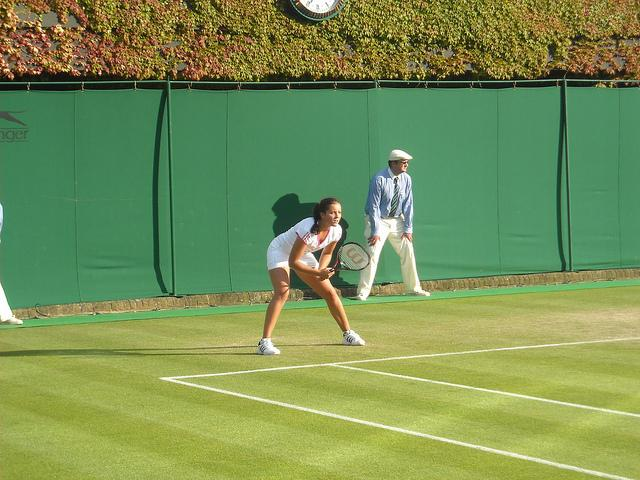Which shadow is the longest? Please explain your reasoning. woman. This person is standing on a flat surface further away from the wall than the other person. 